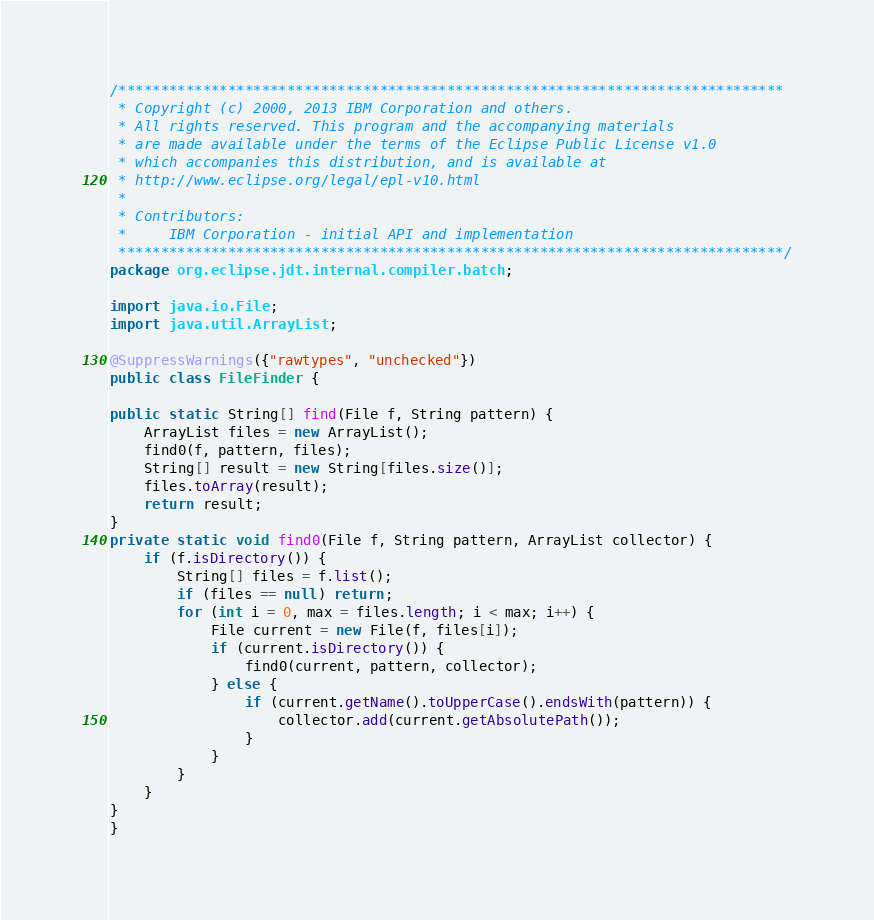Convert code to text. <code><loc_0><loc_0><loc_500><loc_500><_Java_>/*******************************************************************************
 * Copyright (c) 2000, 2013 IBM Corporation and others.
 * All rights reserved. This program and the accompanying materials
 * are made available under the terms of the Eclipse Public License v1.0
 * which accompanies this distribution, and is available at
 * http://www.eclipse.org/legal/epl-v10.html
 *
 * Contributors:
 *     IBM Corporation - initial API and implementation
 *******************************************************************************/
package org.eclipse.jdt.internal.compiler.batch;

import java.io.File;
import java.util.ArrayList;

@SuppressWarnings({"rawtypes", "unchecked"})
public class FileFinder {

public static String[] find(File f, String pattern) {
	ArrayList files = new ArrayList();
	find0(f, pattern, files);
	String[] result = new String[files.size()];
	files.toArray(result);
	return result;
}
private static void find0(File f, String pattern, ArrayList collector) {
	if (f.isDirectory()) {
		String[] files = f.list();
		if (files == null) return;
		for (int i = 0, max = files.length; i < max; i++) {
			File current = new File(f, files[i]);
			if (current.isDirectory()) {
				find0(current, pattern, collector);
			} else {
				if (current.getName().toUpperCase().endsWith(pattern)) {
					collector.add(current.getAbsolutePath());
				}
			}
		}
	}
}
}
</code> 